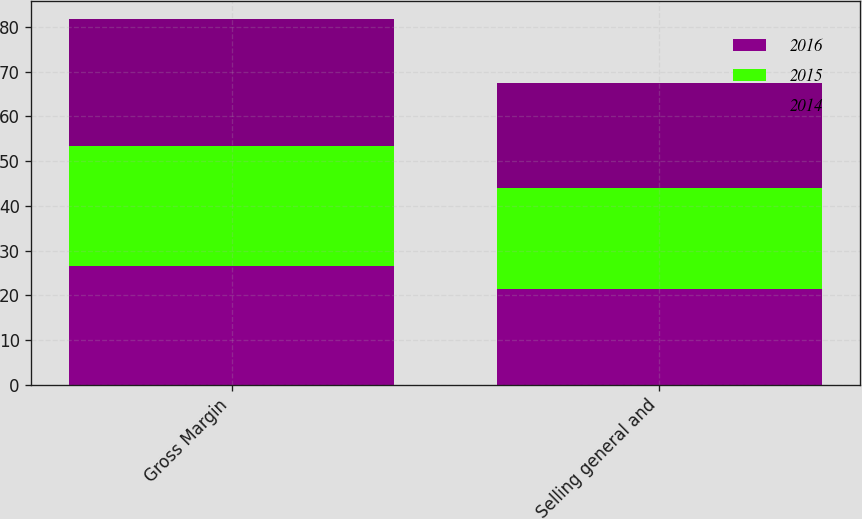Convert chart. <chart><loc_0><loc_0><loc_500><loc_500><stacked_bar_chart><ecel><fcel>Gross Margin<fcel>Selling general and<nl><fcel>2016<fcel>26.6<fcel>21.4<nl><fcel>2015<fcel>26.9<fcel>22.5<nl><fcel>2014<fcel>28.2<fcel>23.6<nl></chart> 